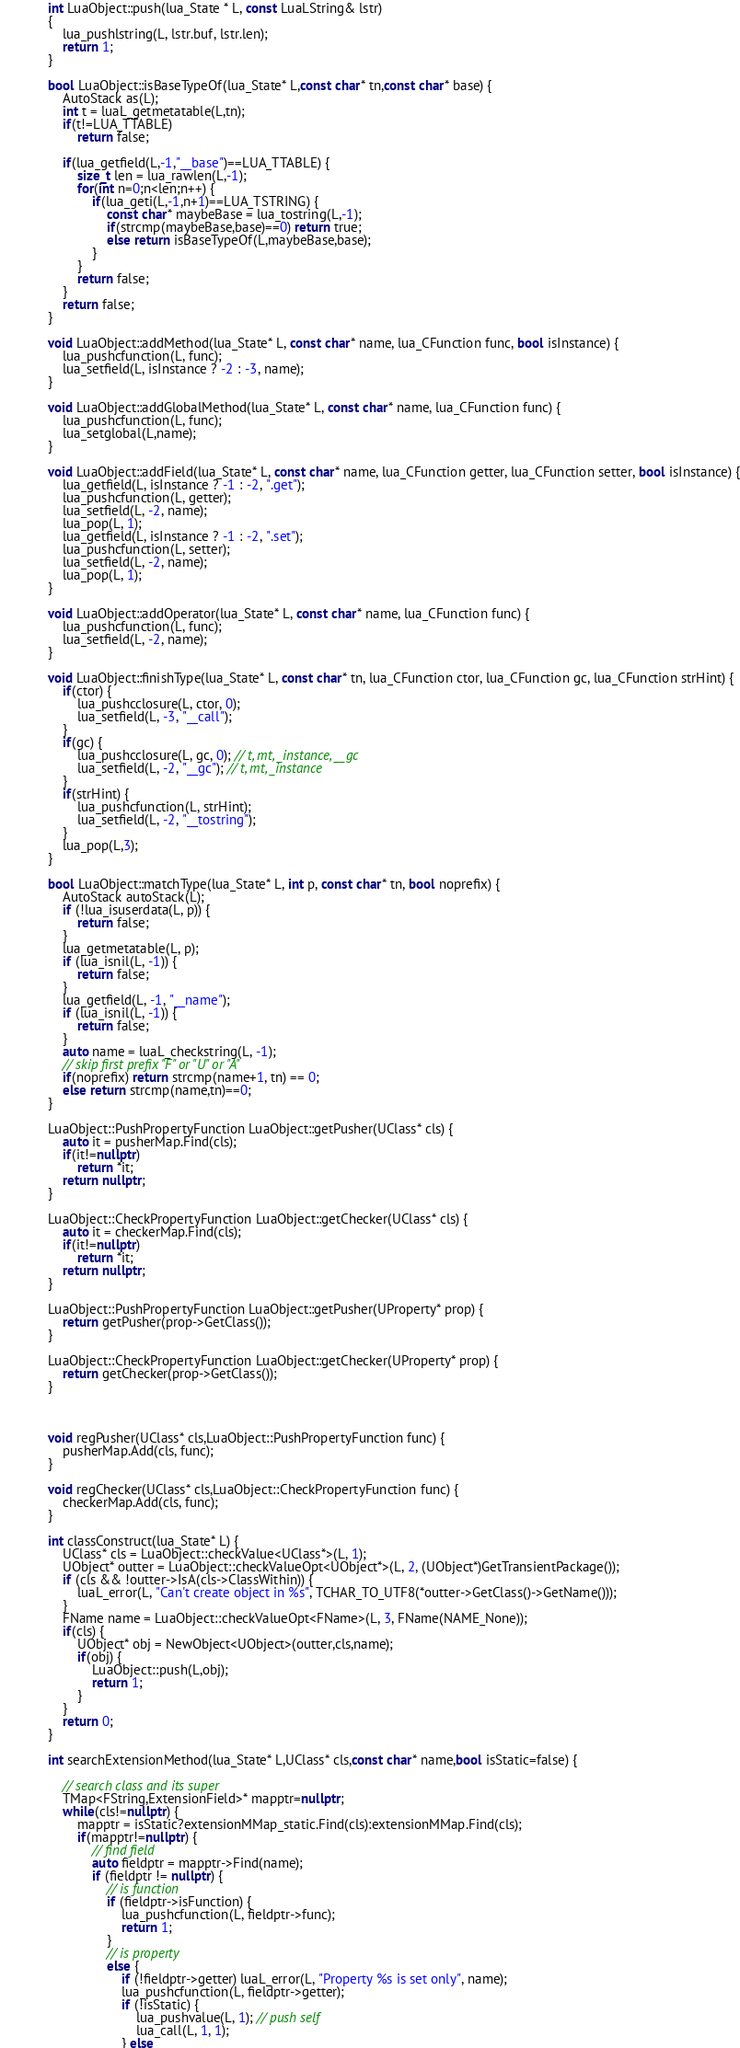Convert code to text. <code><loc_0><loc_0><loc_500><loc_500><_C++_>
	int LuaObject::push(lua_State * L, const LuaLString& lstr)
	{
		lua_pushlstring(L, lstr.buf, lstr.len);
		return 1;
	}

	bool LuaObject::isBaseTypeOf(lua_State* L,const char* tn,const char* base) {
        AutoStack as(L);
        int t = luaL_getmetatable(L,tn);
        if(t!=LUA_TTABLE)
            return false;

        if(lua_getfield(L,-1,"__base")==LUA_TTABLE) {
            size_t len = lua_rawlen(L,-1);
            for(int n=0;n<len;n++) {
                if(lua_geti(L,-1,n+1)==LUA_TSTRING) {
                    const char* maybeBase = lua_tostring(L,-1);
                    if(strcmp(maybeBase,base)==0) return true;
                    else return isBaseTypeOf(L,maybeBase,base);
                }
            }
            return false;
        }
        return false;
    }

	void LuaObject::addMethod(lua_State* L, const char* name, lua_CFunction func, bool isInstance) {
		lua_pushcfunction(L, func);
		lua_setfield(L, isInstance ? -2 : -3, name);
	}

    void LuaObject::addGlobalMethod(lua_State* L, const char* name, lua_CFunction func) {
		lua_pushcfunction(L, func);
        lua_setglobal(L,name);
	}

	void LuaObject::addField(lua_State* L, const char* name, lua_CFunction getter, lua_CFunction setter, bool isInstance) {
		lua_getfield(L, isInstance ? -1 : -2, ".get");
		lua_pushcfunction(L, getter);
		lua_setfield(L, -2, name);
		lua_pop(L, 1);
		lua_getfield(L, isInstance ? -1 : -2, ".set");
		lua_pushcfunction(L, setter);
		lua_setfield(L, -2, name);
		lua_pop(L, 1);
	}

	void LuaObject::addOperator(lua_State* L, const char* name, lua_CFunction func) {
		lua_pushcfunction(L, func);
		lua_setfield(L, -2, name);
	}

	void LuaObject::finishType(lua_State* L, const char* tn, lua_CFunction ctor, lua_CFunction gc, lua_CFunction strHint) {
        if(ctor) {
		    lua_pushcclosure(L, ctor, 0);
		    lua_setfield(L, -3, "__call");
        }
        if(gc) {
		    lua_pushcclosure(L, gc, 0); // t, mt, _instance, __gc
    		lua_setfield(L, -2, "__gc"); // t, mt, _instance
        }
        if(strHint) {
            lua_pushcfunction(L, strHint);
            lua_setfield(L, -2, "__tostring");
        }
        lua_pop(L,3);
	}

	bool LuaObject::matchType(lua_State* L, int p, const char* tn, bool noprefix) {
		AutoStack autoStack(L);
		if (!lua_isuserdata(L, p)) {
			return false;
		}
		lua_getmetatable(L, p);
		if (lua_isnil(L, -1)) {
			return false;
		}
		lua_getfield(L, -1, "__name");
		if (lua_isnil(L, -1)) {
			return false;
		}
		auto name = luaL_checkstring(L, -1);
		// skip first prefix "F" or "U" or "A"
		if(noprefix) return strcmp(name+1, tn) == 0;
		else return strcmp(name,tn)==0;
	}

    LuaObject::PushPropertyFunction LuaObject::getPusher(UClass* cls) {
        auto it = pusherMap.Find(cls);
        if(it!=nullptr)
            return *it;
        return nullptr;
    }

    LuaObject::CheckPropertyFunction LuaObject::getChecker(UClass* cls) {
        auto it = checkerMap.Find(cls);
        if(it!=nullptr)
            return *it;
        return nullptr;
    }

    LuaObject::PushPropertyFunction LuaObject::getPusher(UProperty* prop) {
        return getPusher(prop->GetClass());
    }

    LuaObject::CheckPropertyFunction LuaObject::getChecker(UProperty* prop) {
        return getChecker(prop->GetClass());        
    }

    

    void regPusher(UClass* cls,LuaObject::PushPropertyFunction func) {
		pusherMap.Add(cls, func);
    }

    void regChecker(UClass* cls,LuaObject::CheckPropertyFunction func) {
		checkerMap.Add(cls, func);
    }

    int classConstruct(lua_State* L) {
        UClass* cls = LuaObject::checkValue<UClass*>(L, 1);
		UObject* outter = LuaObject::checkValueOpt<UObject*>(L, 2, (UObject*)GetTransientPackage());
		if (cls && !outter->IsA(cls->ClassWithin)) {
			luaL_error(L, "Can't create object in %s", TCHAR_TO_UTF8(*outter->GetClass()->GetName()));
		}
		FName name = LuaObject::checkValueOpt<FName>(L, 3, FName(NAME_None));
        if(cls) {
            UObject* obj = NewObject<UObject>(outter,cls,name);
            if(obj) {
                LuaObject::push(L,obj);
                return 1;
            }
        }
        return 0;
    }

    int searchExtensionMethod(lua_State* L,UClass* cls,const char* name,bool isStatic=false) {

        // search class and its super
        TMap<FString,ExtensionField>* mapptr=nullptr;
        while(cls!=nullptr) {
            mapptr = isStatic?extensionMMap_static.Find(cls):extensionMMap.Find(cls);
            if(mapptr!=nullptr) {
                // find field
                auto fieldptr = mapptr->Find(name);
				if (fieldptr != nullptr) {
					// is function
					if (fieldptr->isFunction) {
						lua_pushcfunction(L, fieldptr->func);
						return 1;
					} 
					// is property
					else {
						if (!fieldptr->getter) luaL_error(L, "Property %s is set only", name);
						lua_pushcfunction(L, fieldptr->getter);
						if (!isStatic) {
							lua_pushvalue(L, 1); // push self
							lua_call(L, 1, 1);
						} else </code> 